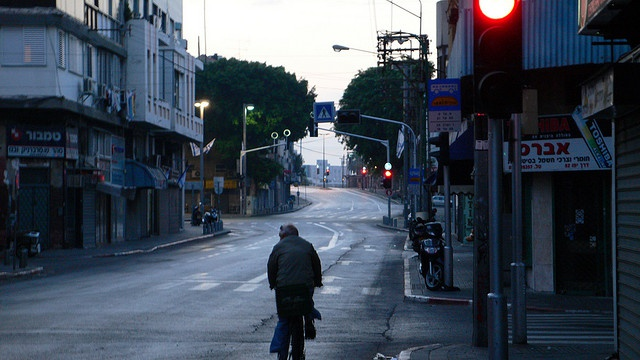Describe the objects in this image and their specific colors. I can see traffic light in black, maroon, white, and red tones, people in black, navy, gray, and blue tones, bicycle in black, gray, and blue tones, motorcycle in black, navy, blue, and gray tones, and motorcycle in black, navy, and blue tones in this image. 